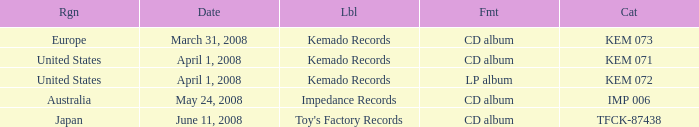Which Format has a Region of united states, and a Catalog of kem 072? LP album. 